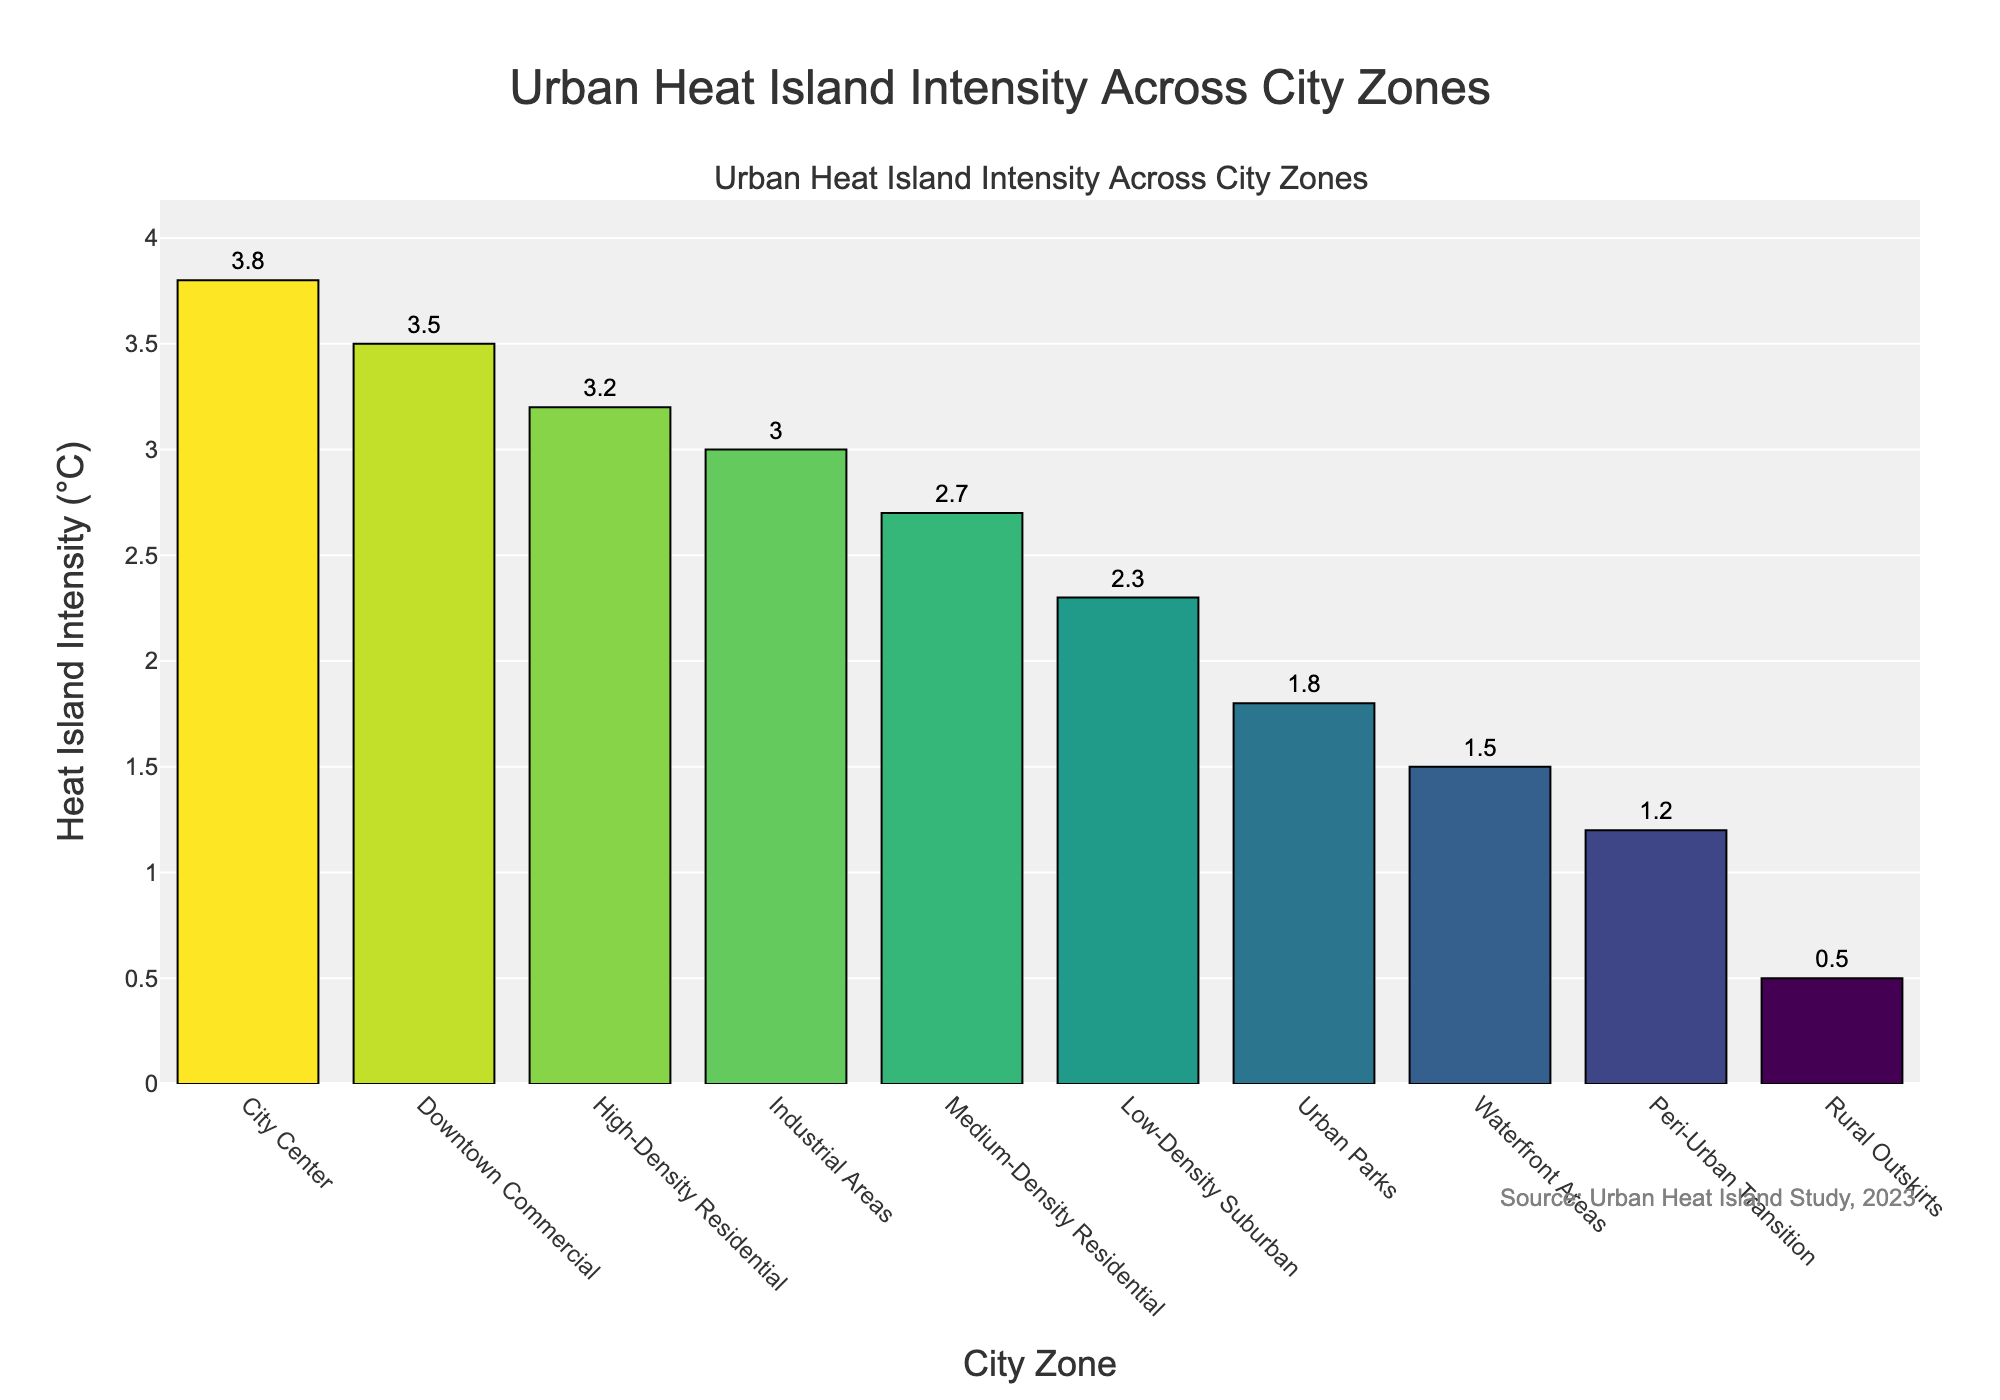What's the city zone with the highest heat island intensity? The city zone with the highest heat island intensity can be identified as the tallest bar in the bar chart.
Answer: City Center What's the difference in heat island intensity between the City Center and the Rural Outskirts? Refer to the heights of the bars for both the City Center and the Rural Outskirts. The City Center has an intensity of 3.8°C and the Rural Outskirts have an intensity of 0.5°C, so the difference is 3.8 - 0.5 = 3.3°C.
Answer: 3.3°C Which city zone has a lower heat island intensity: High-Density Residential or Low-Density Suburban? Compare the heights of the bars for High-Density Residential and Low-Density Suburban. High-Density Residential has an intensity of 3.2°C, while Low-Density Suburban has 2.3°C, so Low-Density Suburban is lower.
Answer: Low-Density Suburban Among "Medium-Density Residential", "Industrial Areas", and "Downtown Commercial", which zone has the median heat island intensity? To find the median value, sort the intensities of these three zones: 3.0°C (Industrial Areas), 3.2°C (High-Density Residential), and 3.5°C (Downtown Commercial). The median value is 3.2°C.
Answer: High-Density Residential What is the sum of heat island intensities for "Urban Parks" and "Waterfront Areas"? Find the heat island intensities of both "Urban Parks" (1.8°C) and "Waterfront Areas" (1.5°C) and add them: 1.8 + 1.5 = 3.3°C.
Answer: 3.3°C Is the heat island intensity of "Industrial Areas" greater than that of "Medium-Density Residential"? Compare the heights of the bars for "Industrial Areas" (3.0°C) and "Medium-Density Residential" (2.7°C). Industrial Areas have a greater heat island intensity.
Answer: Yes Which city zone has the 4th highest heat island intensity? Sort the city zones by heat island intensity in descending order. "High-Density Residential" is the 4th in the list with an intensity of 3.2°C.
Answer: High-Density Residential What is the average heat island intensity of "City Center", "Downtown Commercial", and "Industrial Areas"? Add the heat island intensities of these zones and divide by the number of zones: (3.8 + 3.5 + 3.0) / 3 = 3.43°C.
Answer: 3.43°C What is the range of heat island intensities among all the city zones? Identify the highest and lowest heat island intensities. The highest is City Center at 3.8°C, and the lowest is Rural Outskirts at 0.5°C. The range is 3.8 - 0.5 = 3.3°C.
Answer: 3.3°C 